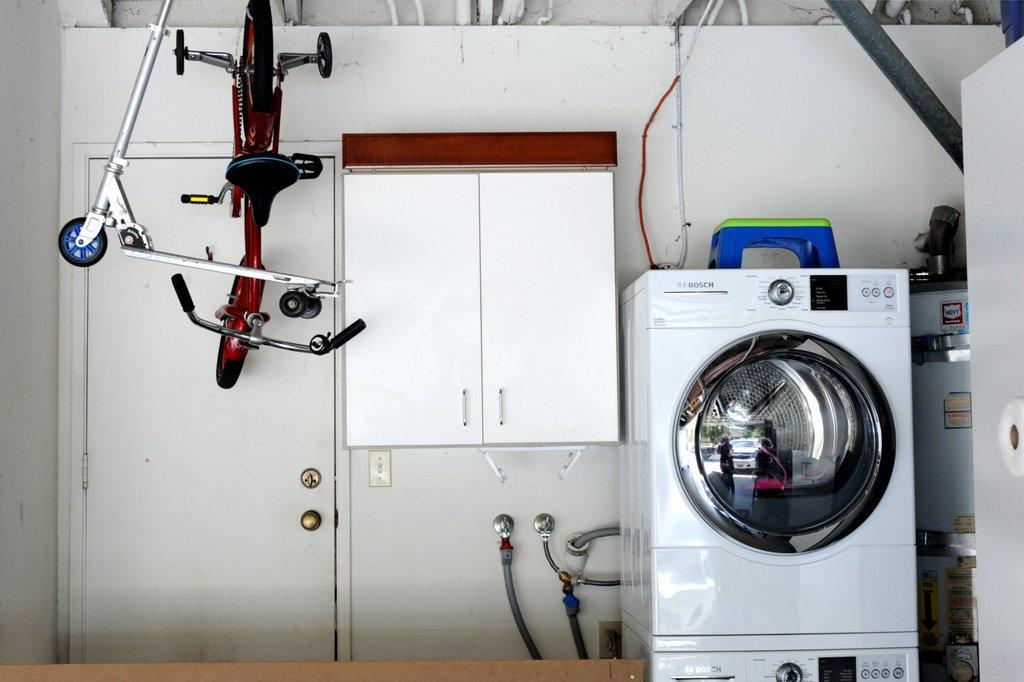What appliance can be seen in the image? There is a washing machine in the image. What is placed on top of the washing machine? There is a table on the washing machine. What type of furniture is present in the image? There is a cupboard in the image. What mode of transportation can be seen hanging on the roof? There are bicycles hanging on the roof in the image. What feature allows access to the room or space? There is a door in the image. What type of cord is attached to the bicycles hanging on the roof? There is no cord visible in the image; the bicycles are hanging without any visible cords. 